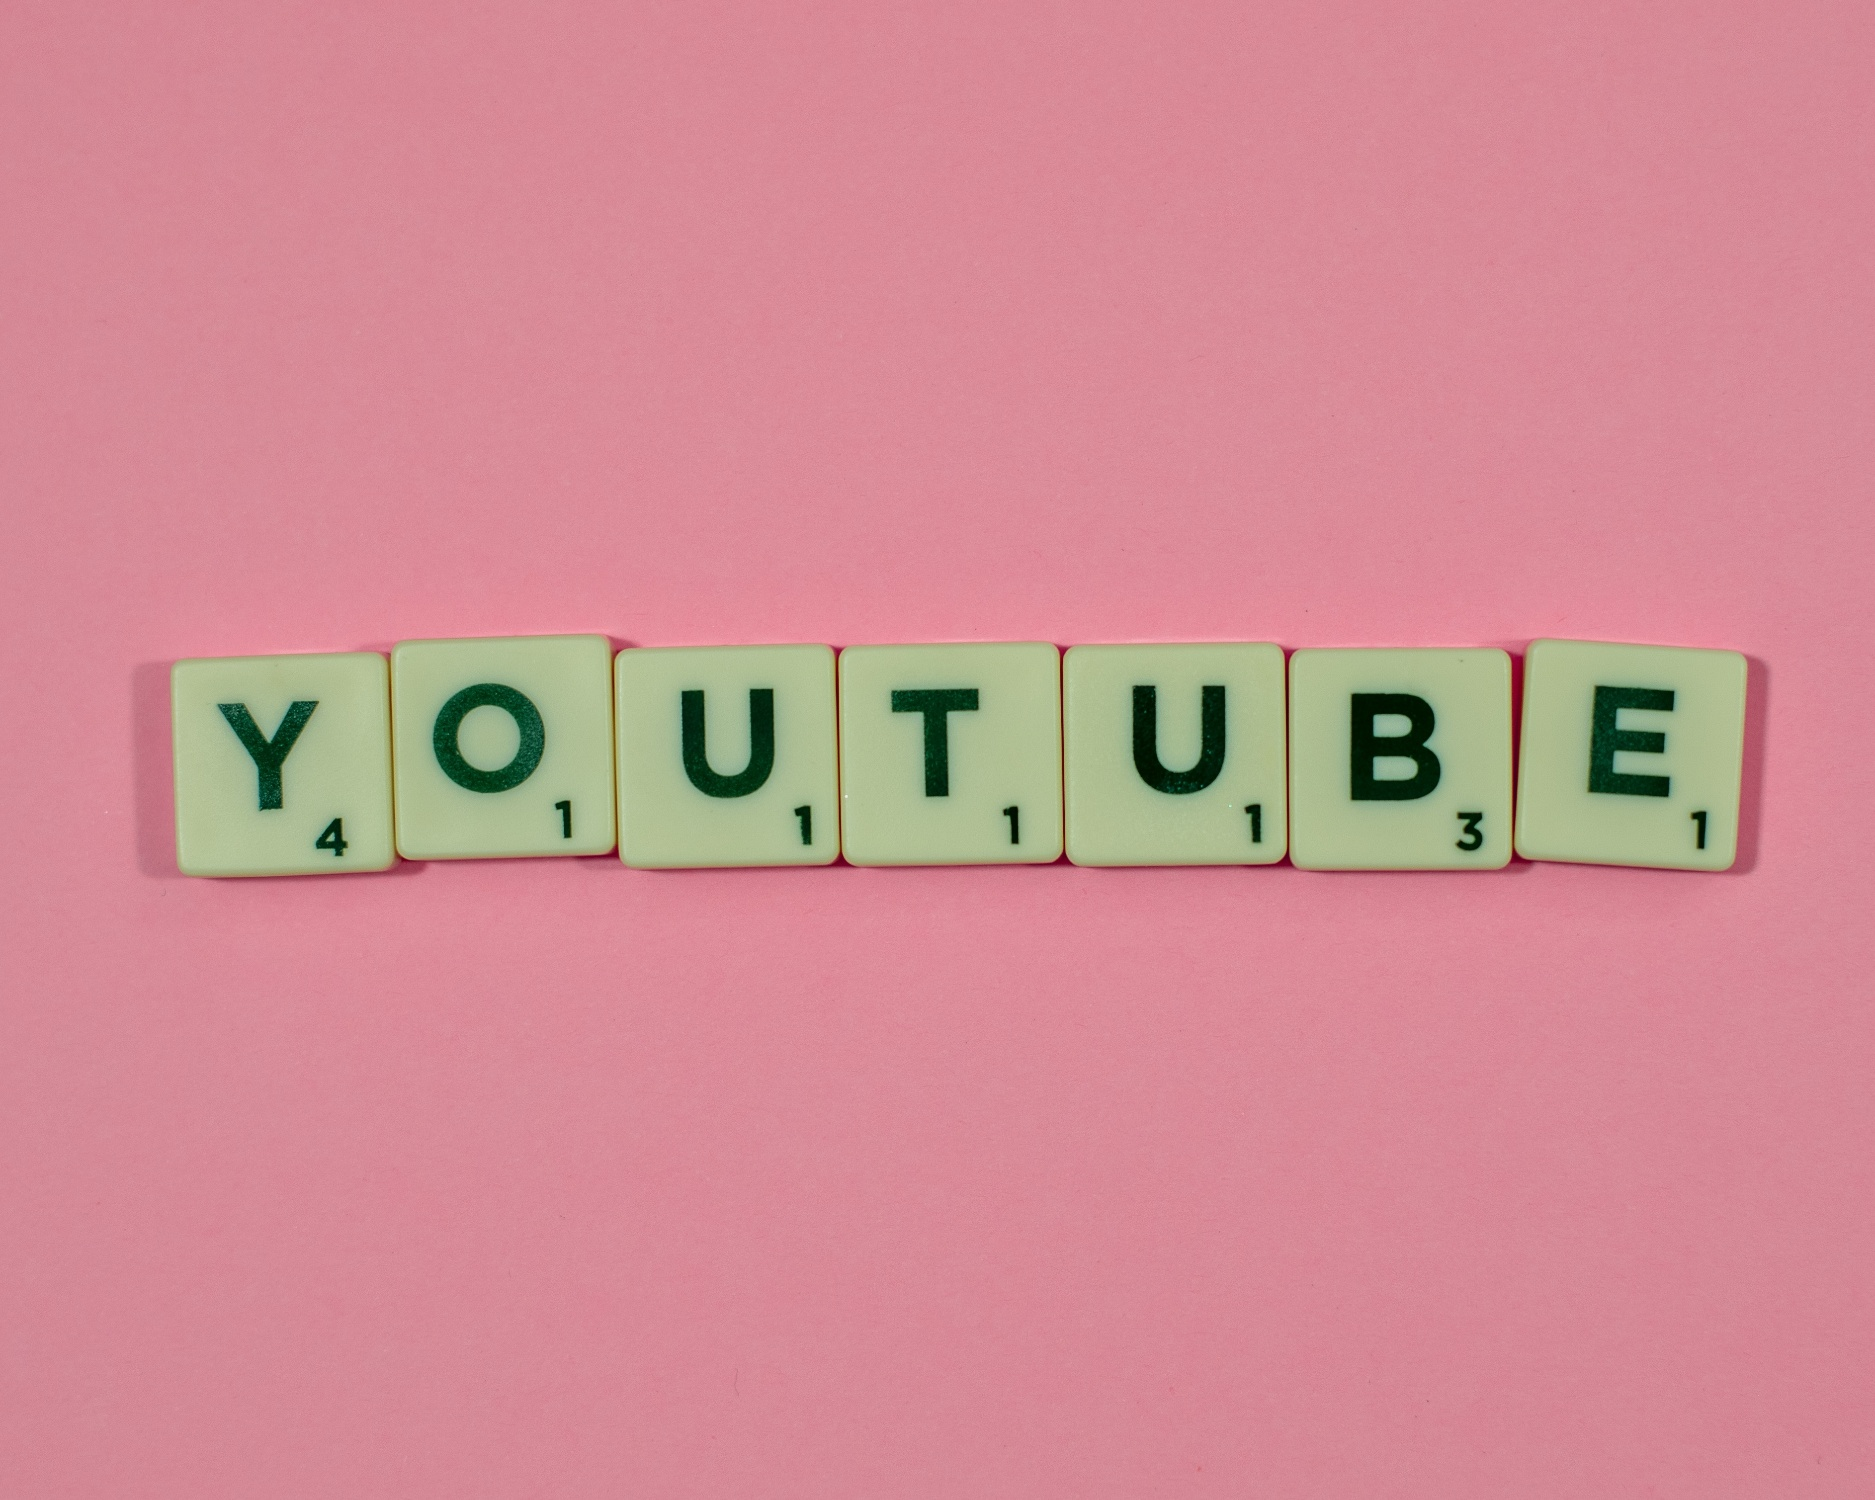Describe a realistic scenario where you might come across this image. You might come across this image while browsing a digital art exhibition online. It could be part of a series showcasing modern interpretations of classic games, reimagined with a twist. Positioned among other innovative and colorful artworks, this image captures attention with its simple yet profound combination of recognizable elements – Scrabble tiles and the word 'YOUTUBE' against a bright pink backdrop. The piece stands out as a playful homage to both word games and digital media culture.  How might this image be integrated into educational content? This image could be integrated into educational content by using it as a visual aid in a lesson about word games and their impact on language skills. For example, in a language arts class, teachers could use the image to discuss the game of Scrabble, how it helps in vocabulary building, and its relevance in modern digital contexts such as YouTube. It can serve as an engaging starting point for activities where students create their own words with Scrabble tiles, discuss the significance of different letters, or even explore digital content creation inspired by the word 'YOUTUBE.' This integration can make learning both interactive and fun, leveraging students' interest in familiar, enjoyable pastimes. 